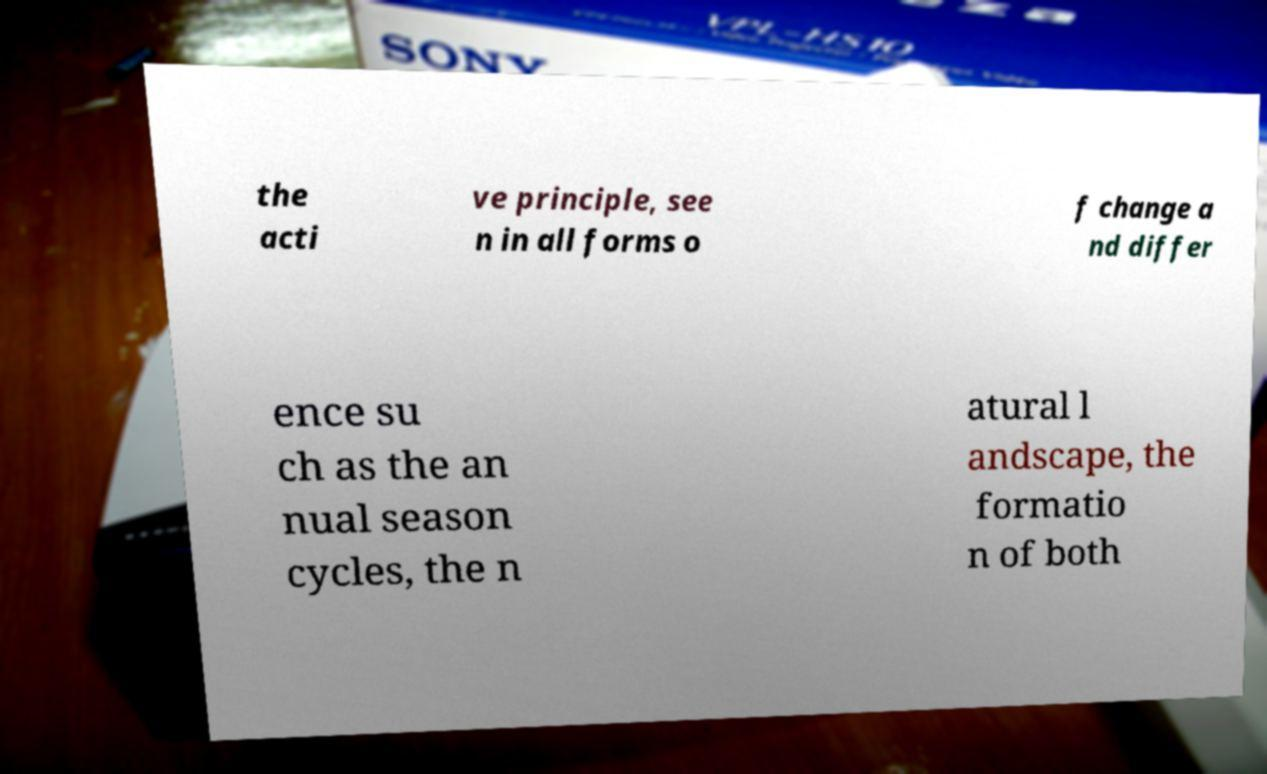Can you read and provide the text displayed in the image?This photo seems to have some interesting text. Can you extract and type it out for me? the acti ve principle, see n in all forms o f change a nd differ ence su ch as the an nual season cycles, the n atural l andscape, the formatio n of both 